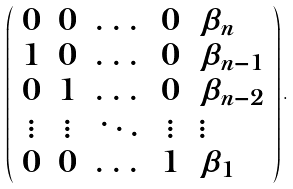<formula> <loc_0><loc_0><loc_500><loc_500>\left ( \begin{array} { c c c c l } 0 & 0 & \dots & 0 & \beta _ { n } \\ 1 & 0 & \dots & 0 & \beta _ { n - 1 } \\ 0 & 1 & \dots & 0 & \beta _ { n - 2 } \\ \vdots & \vdots & \ddots & \vdots & \vdots \\ 0 & 0 & \dots & 1 & \beta _ { 1 } \end{array} \right ) .</formula> 